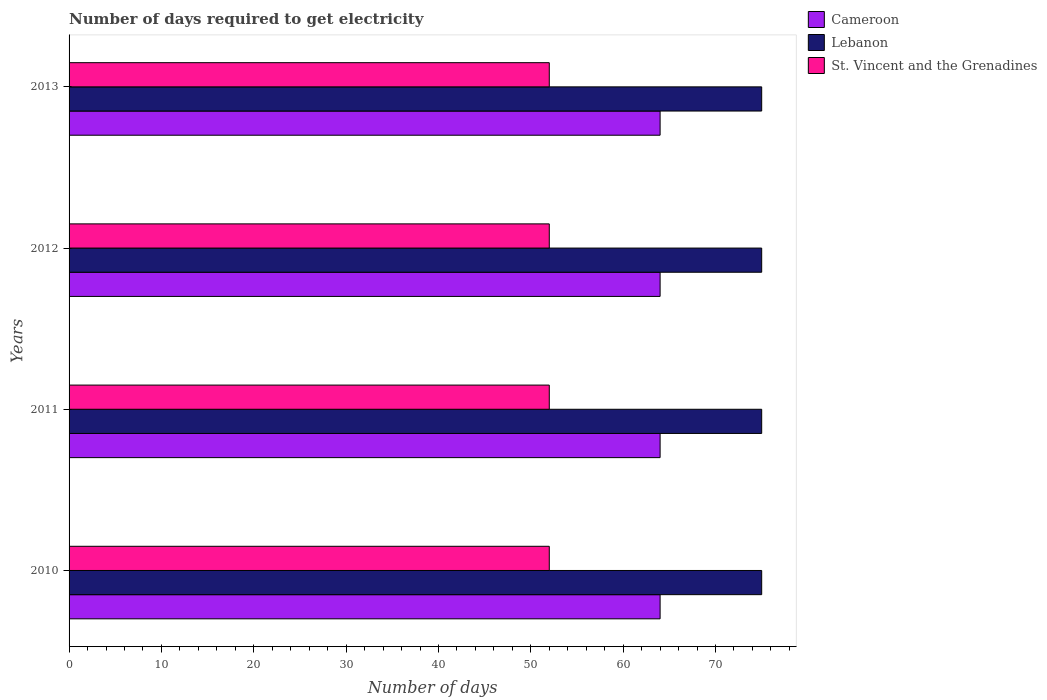Are the number of bars per tick equal to the number of legend labels?
Keep it short and to the point. Yes. Are the number of bars on each tick of the Y-axis equal?
Give a very brief answer. Yes. How many bars are there on the 4th tick from the top?
Make the answer very short. 3. How many bars are there on the 2nd tick from the bottom?
Provide a succinct answer. 3. What is the label of the 4th group of bars from the top?
Provide a succinct answer. 2010. What is the number of days required to get electricity in in St. Vincent and the Grenadines in 2013?
Provide a short and direct response. 52. Across all years, what is the maximum number of days required to get electricity in in Cameroon?
Your answer should be compact. 64. Across all years, what is the minimum number of days required to get electricity in in Cameroon?
Offer a terse response. 64. In which year was the number of days required to get electricity in in St. Vincent and the Grenadines maximum?
Your answer should be compact. 2010. What is the total number of days required to get electricity in in Lebanon in the graph?
Provide a succinct answer. 300. What is the difference between the number of days required to get electricity in in Lebanon in 2010 and that in 2013?
Your response must be concise. 0. What is the difference between the number of days required to get electricity in in St. Vincent and the Grenadines in 2011 and the number of days required to get electricity in in Cameroon in 2013?
Your answer should be compact. -12. What is the average number of days required to get electricity in in Lebanon per year?
Provide a short and direct response. 75. In the year 2012, what is the difference between the number of days required to get electricity in in Cameroon and number of days required to get electricity in in St. Vincent and the Grenadines?
Provide a succinct answer. 12. Is the number of days required to get electricity in in Cameroon in 2010 less than that in 2011?
Offer a terse response. No. What is the difference between the highest and the second highest number of days required to get electricity in in Cameroon?
Provide a short and direct response. 0. In how many years, is the number of days required to get electricity in in Lebanon greater than the average number of days required to get electricity in in Lebanon taken over all years?
Make the answer very short. 0. What does the 3rd bar from the top in 2013 represents?
Provide a succinct answer. Cameroon. What does the 2nd bar from the bottom in 2010 represents?
Provide a short and direct response. Lebanon. Is it the case that in every year, the sum of the number of days required to get electricity in in Cameroon and number of days required to get electricity in in St. Vincent and the Grenadines is greater than the number of days required to get electricity in in Lebanon?
Make the answer very short. Yes. How many bars are there?
Make the answer very short. 12. Are the values on the major ticks of X-axis written in scientific E-notation?
Make the answer very short. No. Does the graph contain any zero values?
Offer a terse response. No. Does the graph contain grids?
Your answer should be very brief. No. How many legend labels are there?
Offer a very short reply. 3. How are the legend labels stacked?
Offer a very short reply. Vertical. What is the title of the graph?
Your response must be concise. Number of days required to get electricity. Does "Saudi Arabia" appear as one of the legend labels in the graph?
Provide a short and direct response. No. What is the label or title of the X-axis?
Your response must be concise. Number of days. What is the Number of days of Lebanon in 2010?
Your answer should be very brief. 75. What is the Number of days in Cameroon in 2011?
Make the answer very short. 64. What is the Number of days in Cameroon in 2012?
Offer a very short reply. 64. What is the Number of days of Lebanon in 2012?
Your response must be concise. 75. What is the Number of days in St. Vincent and the Grenadines in 2012?
Provide a short and direct response. 52. What is the Number of days of Cameroon in 2013?
Ensure brevity in your answer.  64. Across all years, what is the minimum Number of days of Cameroon?
Provide a short and direct response. 64. Across all years, what is the minimum Number of days of St. Vincent and the Grenadines?
Your answer should be compact. 52. What is the total Number of days in Cameroon in the graph?
Make the answer very short. 256. What is the total Number of days in Lebanon in the graph?
Provide a short and direct response. 300. What is the total Number of days of St. Vincent and the Grenadines in the graph?
Offer a very short reply. 208. What is the difference between the Number of days in Cameroon in 2010 and that in 2013?
Ensure brevity in your answer.  0. What is the difference between the Number of days in St. Vincent and the Grenadines in 2010 and that in 2013?
Your answer should be compact. 0. What is the difference between the Number of days of Cameroon in 2011 and that in 2012?
Keep it short and to the point. 0. What is the difference between the Number of days of Lebanon in 2011 and that in 2012?
Your answer should be compact. 0. What is the difference between the Number of days of Cameroon in 2011 and that in 2013?
Make the answer very short. 0. What is the difference between the Number of days in Lebanon in 2012 and that in 2013?
Make the answer very short. 0. What is the difference between the Number of days in St. Vincent and the Grenadines in 2012 and that in 2013?
Make the answer very short. 0. What is the difference between the Number of days in Cameroon in 2010 and the Number of days in Lebanon in 2011?
Keep it short and to the point. -11. What is the difference between the Number of days of Lebanon in 2010 and the Number of days of St. Vincent and the Grenadines in 2011?
Keep it short and to the point. 23. What is the difference between the Number of days of Lebanon in 2010 and the Number of days of St. Vincent and the Grenadines in 2012?
Offer a terse response. 23. What is the difference between the Number of days of Cameroon in 2010 and the Number of days of St. Vincent and the Grenadines in 2013?
Your answer should be very brief. 12. What is the difference between the Number of days in Cameroon in 2011 and the Number of days in Lebanon in 2012?
Ensure brevity in your answer.  -11. What is the difference between the Number of days in Lebanon in 2011 and the Number of days in St. Vincent and the Grenadines in 2012?
Give a very brief answer. 23. What is the difference between the Number of days in Cameroon in 2011 and the Number of days in Lebanon in 2013?
Your answer should be very brief. -11. What is the difference between the Number of days in Cameroon in 2011 and the Number of days in St. Vincent and the Grenadines in 2013?
Make the answer very short. 12. What is the average Number of days in St. Vincent and the Grenadines per year?
Your response must be concise. 52. In the year 2010, what is the difference between the Number of days of Cameroon and Number of days of St. Vincent and the Grenadines?
Ensure brevity in your answer.  12. In the year 2010, what is the difference between the Number of days in Lebanon and Number of days in St. Vincent and the Grenadines?
Keep it short and to the point. 23. In the year 2011, what is the difference between the Number of days in Cameroon and Number of days in Lebanon?
Make the answer very short. -11. In the year 2012, what is the difference between the Number of days of Cameroon and Number of days of Lebanon?
Your answer should be very brief. -11. In the year 2012, what is the difference between the Number of days of Lebanon and Number of days of St. Vincent and the Grenadines?
Provide a short and direct response. 23. In the year 2013, what is the difference between the Number of days of Cameroon and Number of days of Lebanon?
Keep it short and to the point. -11. In the year 2013, what is the difference between the Number of days of Cameroon and Number of days of St. Vincent and the Grenadines?
Give a very brief answer. 12. In the year 2013, what is the difference between the Number of days in Lebanon and Number of days in St. Vincent and the Grenadines?
Your answer should be very brief. 23. What is the ratio of the Number of days in Lebanon in 2010 to that in 2011?
Provide a short and direct response. 1. What is the ratio of the Number of days of St. Vincent and the Grenadines in 2010 to that in 2012?
Make the answer very short. 1. What is the ratio of the Number of days of Cameroon in 2010 to that in 2013?
Your answer should be very brief. 1. What is the ratio of the Number of days of Lebanon in 2010 to that in 2013?
Provide a succinct answer. 1. What is the ratio of the Number of days in St. Vincent and the Grenadines in 2010 to that in 2013?
Your answer should be very brief. 1. What is the ratio of the Number of days of Cameroon in 2011 to that in 2013?
Keep it short and to the point. 1. What is the ratio of the Number of days of Cameroon in 2012 to that in 2013?
Your answer should be very brief. 1. What is the ratio of the Number of days in Lebanon in 2012 to that in 2013?
Your response must be concise. 1. What is the ratio of the Number of days of St. Vincent and the Grenadines in 2012 to that in 2013?
Provide a short and direct response. 1. What is the difference between the highest and the second highest Number of days of Cameroon?
Your answer should be compact. 0. What is the difference between the highest and the second highest Number of days of Lebanon?
Offer a very short reply. 0. What is the difference between the highest and the second highest Number of days in St. Vincent and the Grenadines?
Make the answer very short. 0. What is the difference between the highest and the lowest Number of days in Cameroon?
Give a very brief answer. 0. 